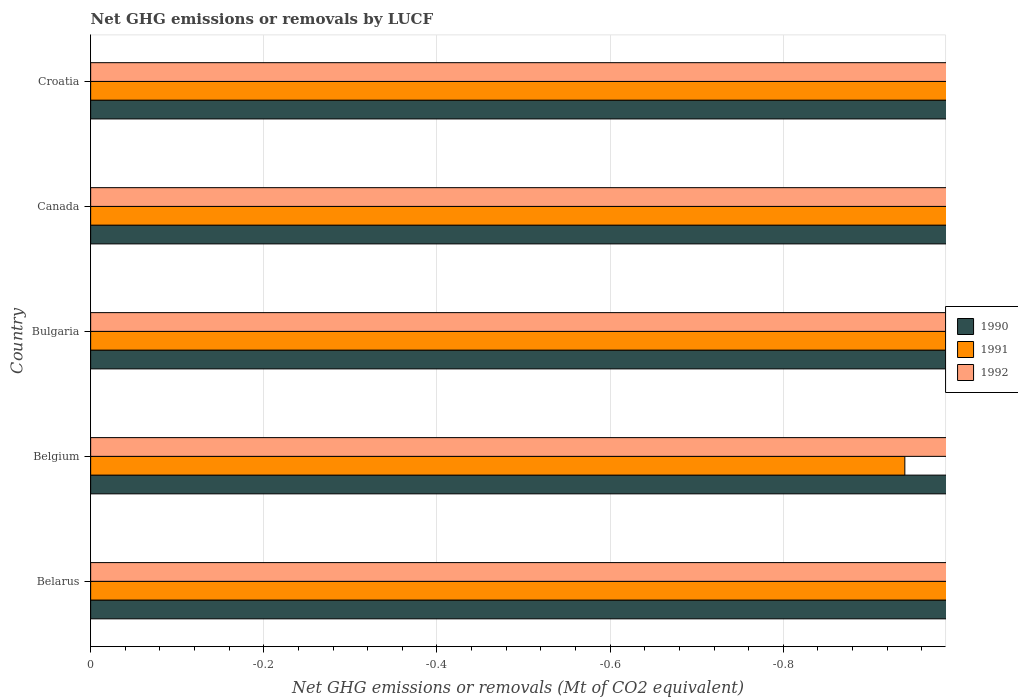How many different coloured bars are there?
Ensure brevity in your answer.  0. Are the number of bars per tick equal to the number of legend labels?
Keep it short and to the point. No. What is the label of the 5th group of bars from the top?
Your answer should be very brief. Belarus. In how many countries, is the net GHG emissions or removals by LUCF in 1992 greater than the average net GHG emissions or removals by LUCF in 1992 taken over all countries?
Your answer should be compact. 0. How many bars are there?
Ensure brevity in your answer.  0. Are all the bars in the graph horizontal?
Ensure brevity in your answer.  Yes. What is the difference between two consecutive major ticks on the X-axis?
Your answer should be compact. 0.2. Are the values on the major ticks of X-axis written in scientific E-notation?
Keep it short and to the point. No. Does the graph contain any zero values?
Keep it short and to the point. Yes. How many legend labels are there?
Your response must be concise. 3. How are the legend labels stacked?
Ensure brevity in your answer.  Vertical. What is the title of the graph?
Your answer should be compact. Net GHG emissions or removals by LUCF. What is the label or title of the X-axis?
Ensure brevity in your answer.  Net GHG emissions or removals (Mt of CO2 equivalent). What is the label or title of the Y-axis?
Ensure brevity in your answer.  Country. What is the Net GHG emissions or removals (Mt of CO2 equivalent) of 1990 in Belarus?
Ensure brevity in your answer.  0. What is the Net GHG emissions or removals (Mt of CO2 equivalent) of 1991 in Belarus?
Offer a terse response. 0. What is the Net GHG emissions or removals (Mt of CO2 equivalent) in 1992 in Belarus?
Give a very brief answer. 0. What is the Net GHG emissions or removals (Mt of CO2 equivalent) of 1992 in Belgium?
Make the answer very short. 0. What is the Net GHG emissions or removals (Mt of CO2 equivalent) in 1991 in Bulgaria?
Make the answer very short. 0. What is the Net GHG emissions or removals (Mt of CO2 equivalent) in 1992 in Bulgaria?
Provide a short and direct response. 0. What is the Net GHG emissions or removals (Mt of CO2 equivalent) in 1990 in Croatia?
Make the answer very short. 0. What is the Net GHG emissions or removals (Mt of CO2 equivalent) in 1991 in Croatia?
Your response must be concise. 0. What is the Net GHG emissions or removals (Mt of CO2 equivalent) of 1992 in Croatia?
Your answer should be compact. 0. What is the total Net GHG emissions or removals (Mt of CO2 equivalent) in 1991 in the graph?
Your response must be concise. 0. What is the average Net GHG emissions or removals (Mt of CO2 equivalent) in 1992 per country?
Offer a terse response. 0. 